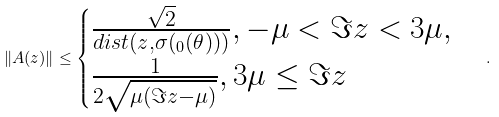Convert formula to latex. <formula><loc_0><loc_0><loc_500><loc_500>\| A ( z ) \| \leq \begin{cases} \frac { \sqrt { 2 } } { d i s t ( z , \sigma ( \L _ { 0 } ( \theta ) ) ) } , - \mu < \Im z < 3 \mu , \\ \frac { 1 } { 2 \sqrt { \mu ( \Im z - \mu ) } } , 3 \mu \leq \Im z \end{cases} .</formula> 